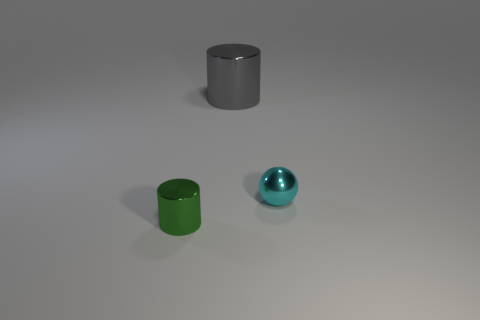Does the shiny cylinder behind the green object have the same size as the metal cylinder in front of the gray cylinder?
Your answer should be very brief. No. Is there another matte object that has the same shape as the tiny cyan object?
Make the answer very short. No. Are there an equal number of small spheres on the left side of the small cyan thing and small metallic cylinders?
Ensure brevity in your answer.  No. There is a gray cylinder; is it the same size as the thing that is in front of the cyan object?
Keep it short and to the point. No. How many other tiny green cylinders have the same material as the small green cylinder?
Your answer should be very brief. 0. Is the size of the green shiny cylinder the same as the metallic ball?
Provide a short and direct response. Yes. Is there any other thing that is the same color as the big metal cylinder?
Provide a short and direct response. No. What is the shape of the thing that is on the left side of the tiny shiny ball and on the right side of the green metal cylinder?
Offer a very short reply. Cylinder. What is the size of the metal cylinder that is to the right of the small metallic cylinder?
Offer a terse response. Large. How many green objects are behind the tiny shiny object behind the cylinder that is in front of the large metal cylinder?
Your response must be concise. 0. 